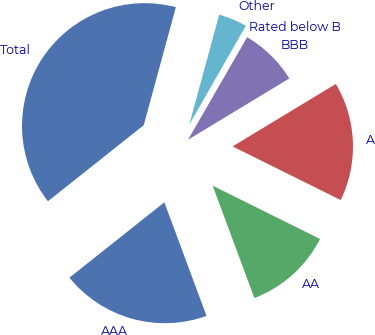Convert chart. <chart><loc_0><loc_0><loc_500><loc_500><pie_chart><fcel>AAA<fcel>AA<fcel>A<fcel>BBB<fcel>Rated below B<fcel>Other<fcel>Total<nl><fcel>19.98%<fcel>12.01%<fcel>15.99%<fcel>8.02%<fcel>0.05%<fcel>4.04%<fcel>39.91%<nl></chart> 